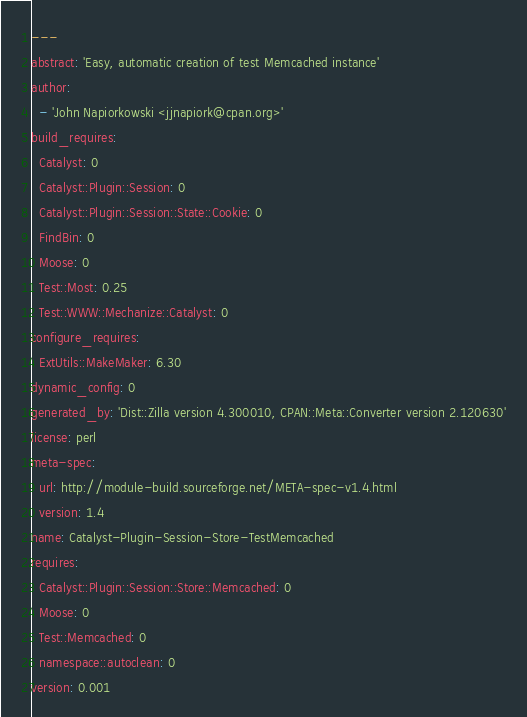Convert code to text. <code><loc_0><loc_0><loc_500><loc_500><_YAML_>---
abstract: 'Easy, automatic creation of test Memcached instance'
author:
  - 'John Napiorkowski <jjnapiork@cpan.org>'
build_requires:
  Catalyst: 0
  Catalyst::Plugin::Session: 0
  Catalyst::Plugin::Session::State::Cookie: 0
  FindBin: 0
  Moose: 0
  Test::Most: 0.25
  Test::WWW::Mechanize::Catalyst: 0
configure_requires:
  ExtUtils::MakeMaker: 6.30
dynamic_config: 0
generated_by: 'Dist::Zilla version 4.300010, CPAN::Meta::Converter version 2.120630'
license: perl
meta-spec:
  url: http://module-build.sourceforge.net/META-spec-v1.4.html
  version: 1.4
name: Catalyst-Plugin-Session-Store-TestMemcached
requires:
  Catalyst::Plugin::Session::Store::Memcached: 0
  Moose: 0
  Test::Memcached: 0
  namespace::autoclean: 0
version: 0.001
</code> 